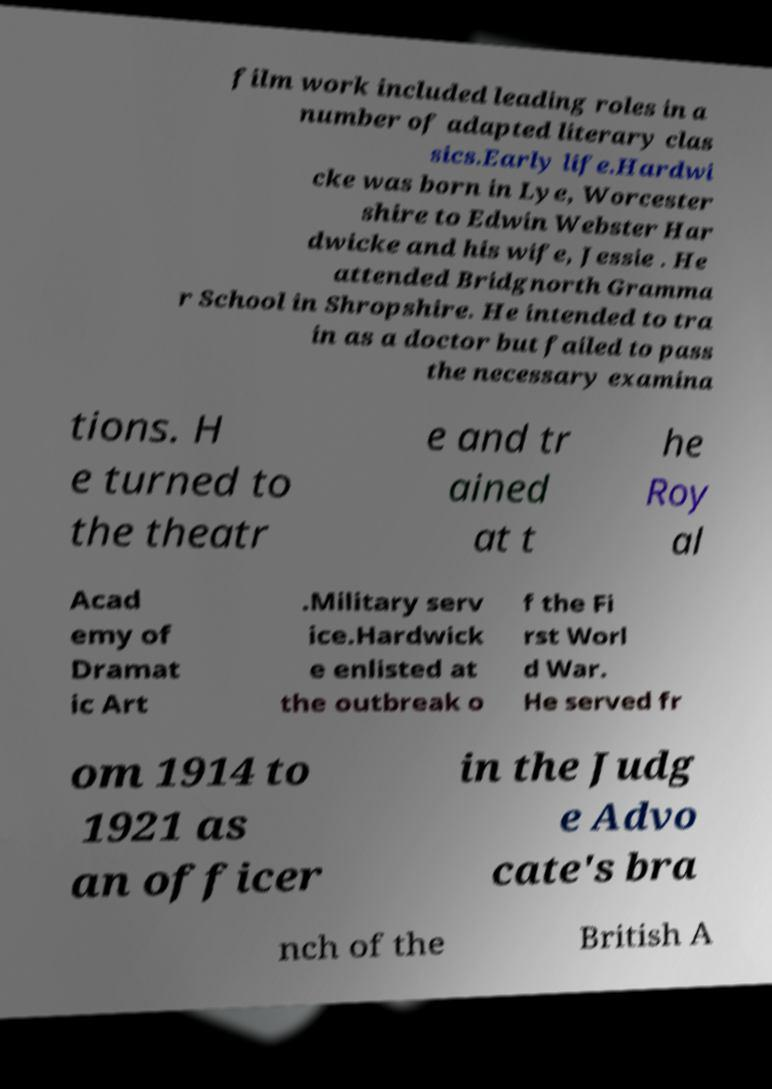Please identify and transcribe the text found in this image. film work included leading roles in a number of adapted literary clas sics.Early life.Hardwi cke was born in Lye, Worcester shire to Edwin Webster Har dwicke and his wife, Jessie . He attended Bridgnorth Gramma r School in Shropshire. He intended to tra in as a doctor but failed to pass the necessary examina tions. H e turned to the theatr e and tr ained at t he Roy al Acad emy of Dramat ic Art .Military serv ice.Hardwick e enlisted at the outbreak o f the Fi rst Worl d War. He served fr om 1914 to 1921 as an officer in the Judg e Advo cate's bra nch of the British A 